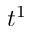Convert formula to latex. <formula><loc_0><loc_0><loc_500><loc_500>t ^ { 1 }</formula> 